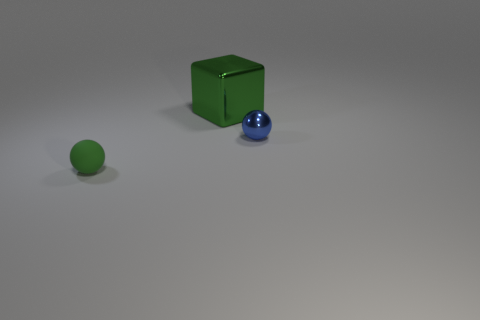Is the big block the same color as the small matte ball?
Your answer should be compact. Yes. There is a metal thing that is to the left of the blue object; is it the same color as the small matte sphere?
Ensure brevity in your answer.  Yes. Are there any other things that have the same color as the block?
Make the answer very short. Yes. Is there anything else that is the same size as the green metal object?
Provide a short and direct response. No. There is a small object that is on the left side of the big thing; is its color the same as the metallic object left of the small blue shiny thing?
Offer a very short reply. Yes. The small rubber thing that is the same color as the big block is what shape?
Offer a terse response. Sphere. The tiny sphere that is on the right side of the green thing that is in front of the ball that is right of the big green cube is what color?
Give a very brief answer. Blue. What is the size of the thing that is behind the small green matte thing and left of the tiny shiny ball?
Provide a succinct answer. Large. What number of other objects are there of the same shape as the green metallic thing?
Your answer should be compact. 0. How many cubes are either tiny gray metallic things or small shiny things?
Offer a very short reply. 0. 